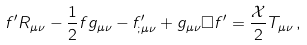Convert formula to latex. <formula><loc_0><loc_0><loc_500><loc_500>f ^ { \prime } R _ { \mu \nu } - \frac { 1 } { 2 } f g _ { \mu \nu } - f ^ { \prime } _ { ; \mu \nu } + g _ { \mu \nu } \Box f ^ { \prime } = \frac { \mathcal { X } } { 2 } T _ { \mu \nu } \, ,</formula> 